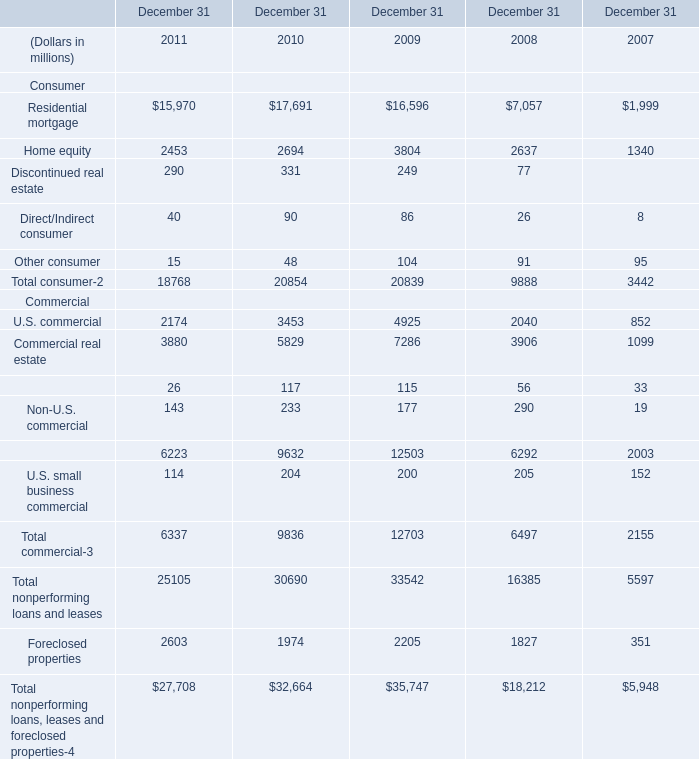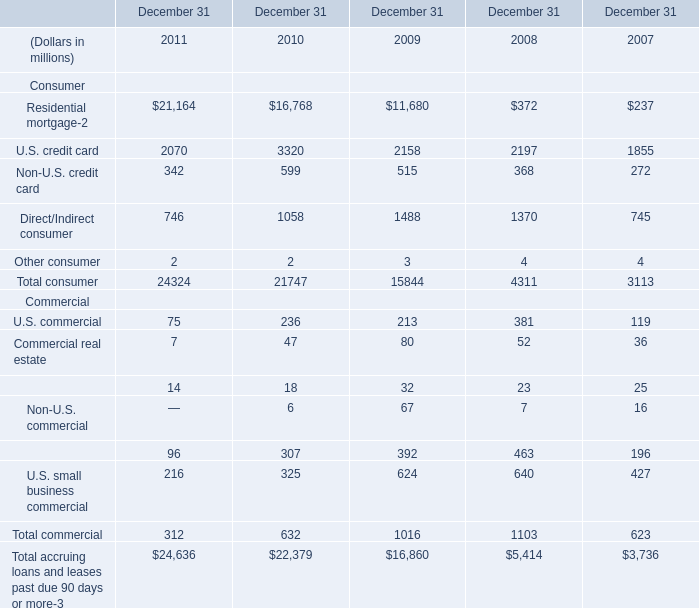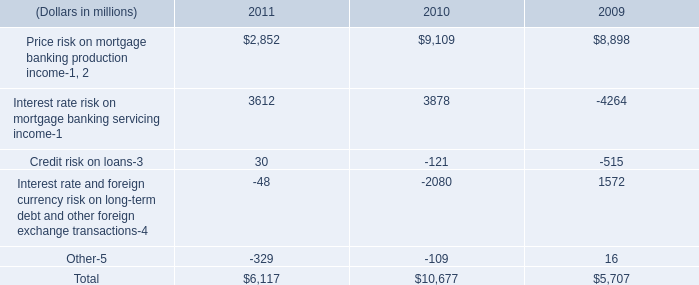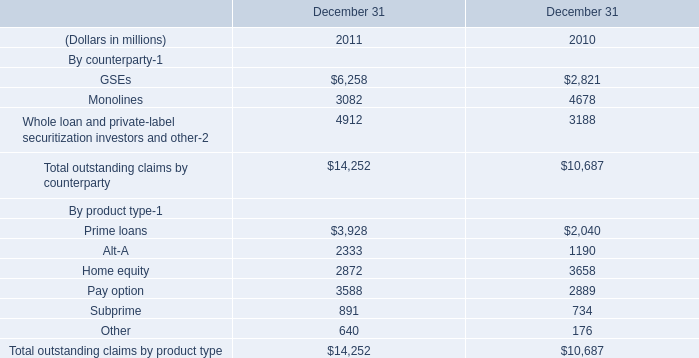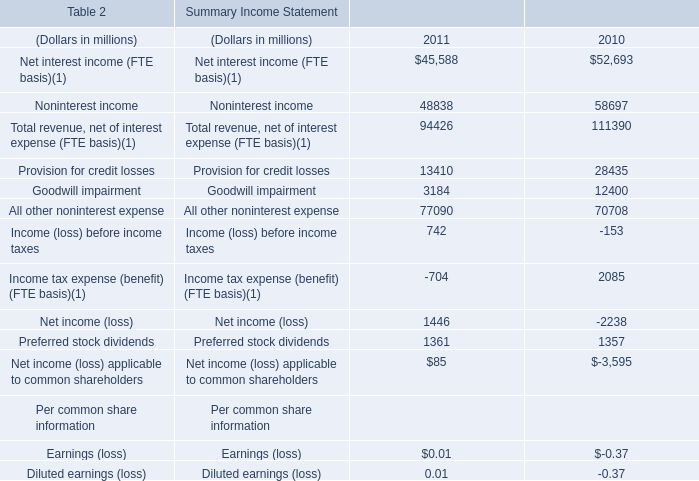What is the difference between the greatest Consumer in 2011 and 2010？ (in million) 
Computations: (21164 - 16768)
Answer: 4396.0. 